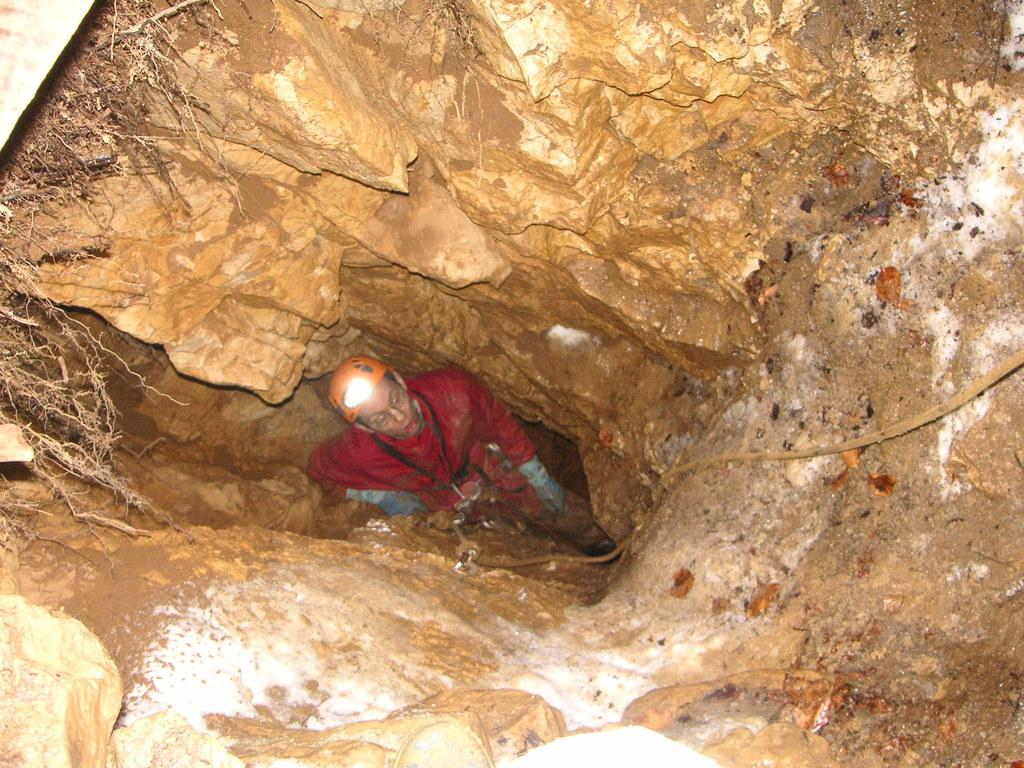What is the person in the image doing? There is a person digging a small cave in the image. What can be seen on the left side of the image? There are roots on the left side of the image. What is visible in the background of the image? There are rocks visible in the background of the image. What is the purpose of the bell in the image? There is no bell present in the image. 